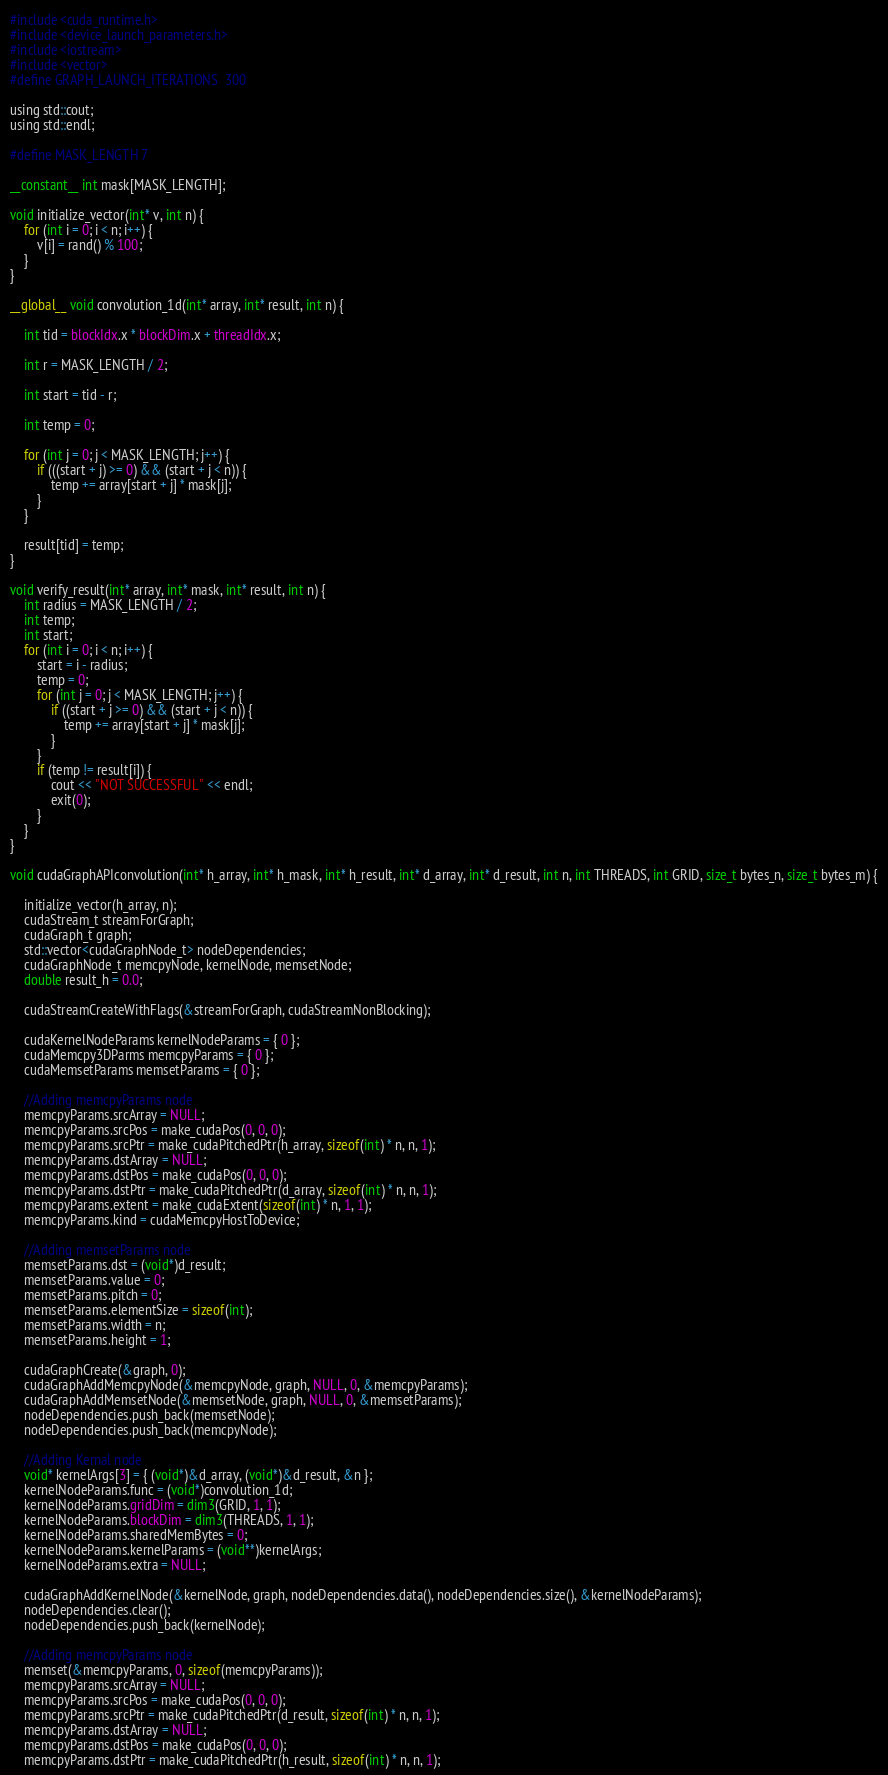<code> <loc_0><loc_0><loc_500><loc_500><_Cuda_>#include <cuda_runtime.h>
#include <device_launch_parameters.h>
#include <iostream>
#include <vector>
#define GRAPH_LAUNCH_ITERATIONS  300

using std::cout;
using std::endl;

#define MASK_LENGTH 7

__constant__ int mask[MASK_LENGTH];

void initialize_vector(int* v, int n) {
    for (int i = 0; i < n; i++) {
        v[i] = rand() % 100;
    }
}

__global__ void convolution_1d(int* array, int* result, int n) {

    int tid = blockIdx.x * blockDim.x + threadIdx.x;

    int r = MASK_LENGTH / 2;

    int start = tid - r;

    int temp = 0;

    for (int j = 0; j < MASK_LENGTH; j++) {
        if (((start + j) >= 0) && (start + j < n)) {
            temp += array[start + j] * mask[j];
        }
    }

    result[tid] = temp;
}

void verify_result(int* array, int* mask, int* result, int n) {
    int radius = MASK_LENGTH / 2;
    int temp;
    int start;
    for (int i = 0; i < n; i++) {
        start = i - radius;
        temp = 0;
        for (int j = 0; j < MASK_LENGTH; j++) {
            if ((start + j >= 0) && (start + j < n)) {
                temp += array[start + j] * mask[j];
            }
        }
        if (temp != result[i]) {
            cout << "NOT SUCCESSFUL" << endl;
            exit(0);
        }
    }
}

void cudaGraphAPIconvolution(int* h_array, int* h_mask, int* h_result, int* d_array, int* d_result, int n, int THREADS, int GRID, size_t bytes_n, size_t bytes_m) {

    initialize_vector(h_array, n);
    cudaStream_t streamForGraph;
    cudaGraph_t graph;
    std::vector<cudaGraphNode_t> nodeDependencies;
    cudaGraphNode_t memcpyNode, kernelNode, memsetNode;
    double result_h = 0.0;

    cudaStreamCreateWithFlags(&streamForGraph, cudaStreamNonBlocking);

    cudaKernelNodeParams kernelNodeParams = { 0 };
    cudaMemcpy3DParms memcpyParams = { 0 };
    cudaMemsetParams memsetParams = { 0 };

    //Adding memcpyParams node
    memcpyParams.srcArray = NULL;
    memcpyParams.srcPos = make_cudaPos(0, 0, 0);
    memcpyParams.srcPtr = make_cudaPitchedPtr(h_array, sizeof(int) * n, n, 1);
    memcpyParams.dstArray = NULL;
    memcpyParams.dstPos = make_cudaPos(0, 0, 0);
    memcpyParams.dstPtr = make_cudaPitchedPtr(d_array, sizeof(int) * n, n, 1);
    memcpyParams.extent = make_cudaExtent(sizeof(int) * n, 1, 1);
    memcpyParams.kind = cudaMemcpyHostToDevice;

    //Adding memsetParams node
    memsetParams.dst = (void*)d_result;
    memsetParams.value = 0;
    memsetParams.pitch = 0;
    memsetParams.elementSize = sizeof(int);
    memsetParams.width = n;
    memsetParams.height = 1;

    cudaGraphCreate(&graph, 0);
    cudaGraphAddMemcpyNode(&memcpyNode, graph, NULL, 0, &memcpyParams);
    cudaGraphAddMemsetNode(&memsetNode, graph, NULL, 0, &memsetParams);
    nodeDependencies.push_back(memsetNode);
    nodeDependencies.push_back(memcpyNode);

    //Adding Kernal node
    void* kernelArgs[3] = { (void*)&d_array, (void*)&d_result, &n };
    kernelNodeParams.func = (void*)convolution_1d;
    kernelNodeParams.gridDim = dim3(GRID, 1, 1);
    kernelNodeParams.blockDim = dim3(THREADS, 1, 1);
    kernelNodeParams.sharedMemBytes = 0;
    kernelNodeParams.kernelParams = (void**)kernelArgs;
    kernelNodeParams.extra = NULL;

    cudaGraphAddKernelNode(&kernelNode, graph, nodeDependencies.data(), nodeDependencies.size(), &kernelNodeParams);
    nodeDependencies.clear();
    nodeDependencies.push_back(kernelNode);

    //Adding memcpyParams node
    memset(&memcpyParams, 0, sizeof(memcpyParams));
    memcpyParams.srcArray = NULL;
    memcpyParams.srcPos = make_cudaPos(0, 0, 0);
    memcpyParams.srcPtr = make_cudaPitchedPtr(d_result, sizeof(int) * n, n, 1);
    memcpyParams.dstArray = NULL;
    memcpyParams.dstPos = make_cudaPos(0, 0, 0);
    memcpyParams.dstPtr = make_cudaPitchedPtr(h_result, sizeof(int) * n, n, 1);</code> 